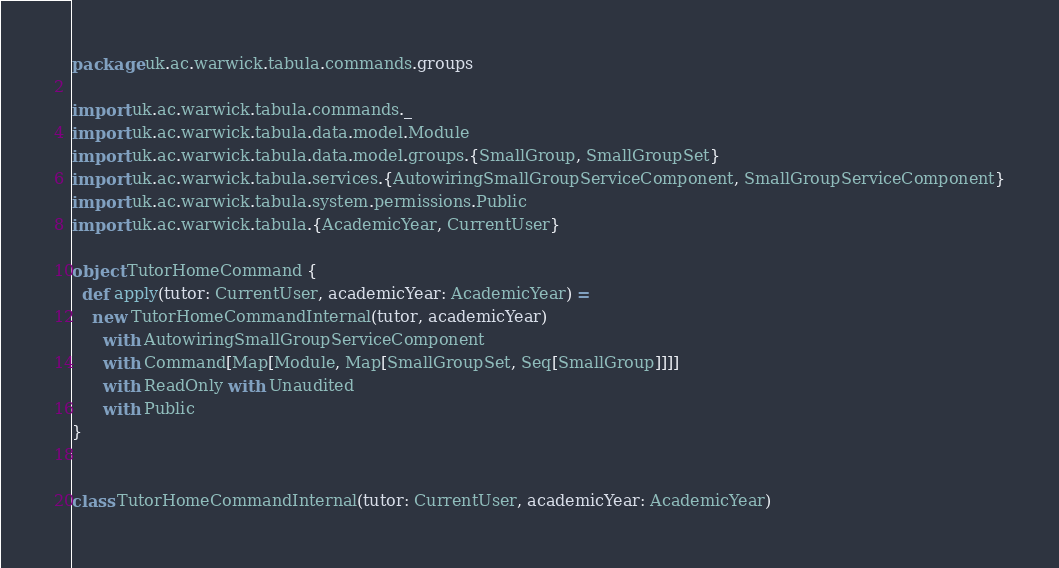Convert code to text. <code><loc_0><loc_0><loc_500><loc_500><_Scala_>package uk.ac.warwick.tabula.commands.groups

import uk.ac.warwick.tabula.commands._
import uk.ac.warwick.tabula.data.model.Module
import uk.ac.warwick.tabula.data.model.groups.{SmallGroup, SmallGroupSet}
import uk.ac.warwick.tabula.services.{AutowiringSmallGroupServiceComponent, SmallGroupServiceComponent}
import uk.ac.warwick.tabula.system.permissions.Public
import uk.ac.warwick.tabula.{AcademicYear, CurrentUser}

object TutorHomeCommand {
  def apply(tutor: CurrentUser, academicYear: AcademicYear) =
    new TutorHomeCommandInternal(tutor, academicYear)
      with AutowiringSmallGroupServiceComponent
      with Command[Map[Module, Map[SmallGroupSet, Seq[SmallGroup]]]]
      with ReadOnly with Unaudited
      with Public
}


class TutorHomeCommandInternal(tutor: CurrentUser, academicYear: AcademicYear)</code> 